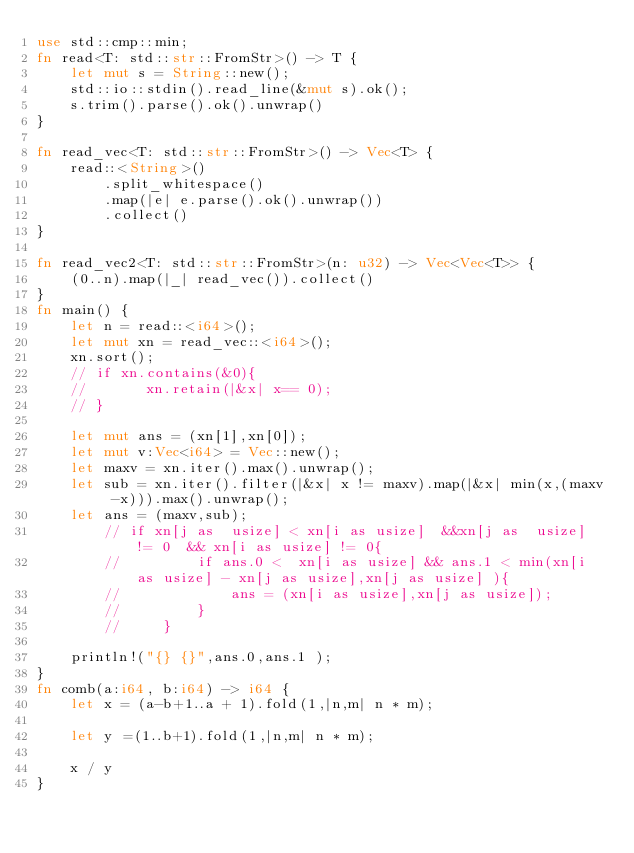Convert code to text. <code><loc_0><loc_0><loc_500><loc_500><_Rust_>use std::cmp::min;
fn read<T: std::str::FromStr>() -> T {
    let mut s = String::new();
    std::io::stdin().read_line(&mut s).ok();
    s.trim().parse().ok().unwrap()
}

fn read_vec<T: std::str::FromStr>() -> Vec<T> {
    read::<String>()
        .split_whitespace()
        .map(|e| e.parse().ok().unwrap())
        .collect()
}

fn read_vec2<T: std::str::FromStr>(n: u32) -> Vec<Vec<T>> {
    (0..n).map(|_| read_vec()).collect()
}
fn main() {
    let n = read::<i64>();
    let mut xn = read_vec::<i64>();
    xn.sort();
    // if xn.contains(&0){
    //       xn.retain(|&x| x== 0);
    // }
  
    let mut ans = (xn[1],xn[0]);
    let mut v:Vec<i64> = Vec::new();
    let maxv = xn.iter().max().unwrap();
    let sub = xn.iter().filter(|&x| x != maxv).map(|&x| min(x,(maxv -x))).max().unwrap();
    let ans = (maxv,sub);
        // if xn[j as  usize] < xn[i as usize]  &&xn[j as  usize] != 0  && xn[i as usize] != 0{
        //         if ans.0 <  xn[i as usize] && ans.1 < min(xn[i as usize] - xn[j as usize],xn[j as usize] ){
        //             ans = (xn[i as usize],xn[j as usize]);
        //         }
        //     }   

    println!("{} {}",ans.0,ans.1 );
}
fn comb(a:i64, b:i64) -> i64 {
    let x = (a-b+1..a + 1).fold(1,|n,m| n * m);
  
    let y =(1..b+1).fold(1,|n,m| n * m);
  
    x / y
}</code> 